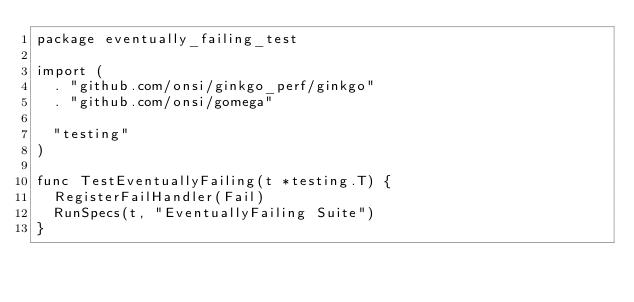<code> <loc_0><loc_0><loc_500><loc_500><_Go_>package eventually_failing_test

import (
	. "github.com/onsi/ginkgo_perf/ginkgo"
	. "github.com/onsi/gomega"

	"testing"
)

func TestEventuallyFailing(t *testing.T) {
	RegisterFailHandler(Fail)
	RunSpecs(t, "EventuallyFailing Suite")
}
</code> 